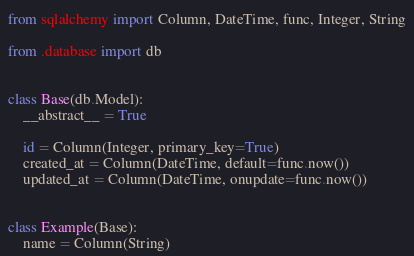<code> <loc_0><loc_0><loc_500><loc_500><_Python_>from sqlalchemy import Column, DateTime, func, Integer, String

from .database import db


class Base(db.Model):
    __abstract__ = True

    id = Column(Integer, primary_key=True)
    created_at = Column(DateTime, default=func.now())
    updated_at = Column(DateTime, onupdate=func.now())


class Example(Base):
    name = Column(String)</code> 